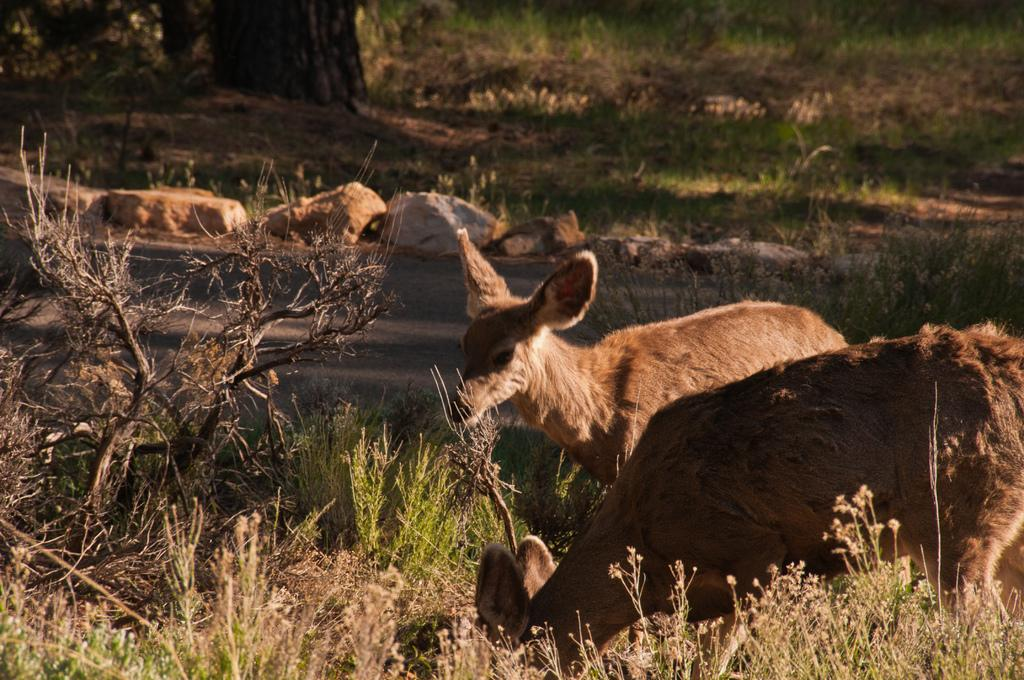What is the main setting of the image? The main setting of the image is an open grass ground. What can be found on the grass ground? There are stones and plants on the grass ground. Are there any animals visible in the image? Yes, there are two deer in the image. What else can be seen in the top left side of the image? There is a tree trunk-like object in the top left side of the image. What type of competition is taking place in the image? There is no competition present in the image; it features an open grass ground with stones, plants, two deer, and a tree trunk-like object. Can you see the sea in the image? No, the sea is not visible in the image; it features an open grass ground with stones, plants, two deer, and a tree trunk-like object. 